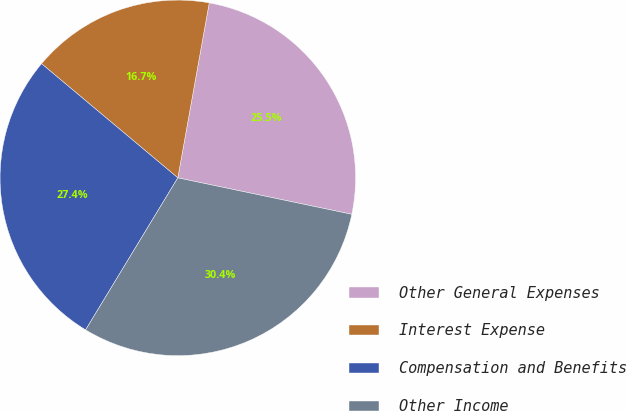Convert chart. <chart><loc_0><loc_0><loc_500><loc_500><pie_chart><fcel>Other General Expenses<fcel>Interest Expense<fcel>Compensation and Benefits<fcel>Other Income<nl><fcel>25.46%<fcel>16.73%<fcel>27.42%<fcel>30.39%<nl></chart> 